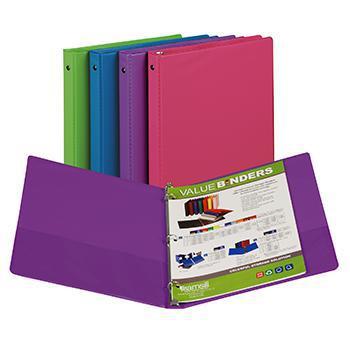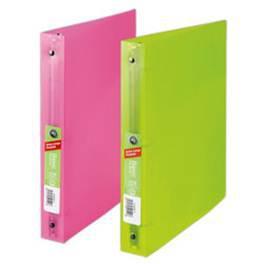The first image is the image on the left, the second image is the image on the right. Assess this claim about the two images: "The right image image depicts no more than three binders.". Correct or not? Answer yes or no. Yes. 